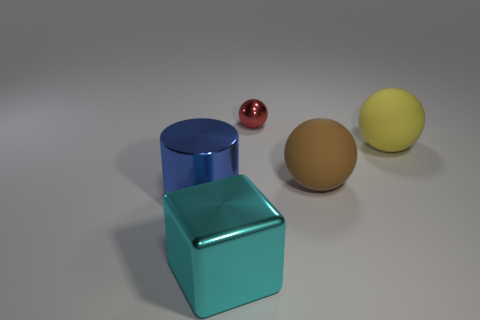Subtract all yellow matte balls. How many balls are left? 2 Subtract all red spheres. How many spheres are left? 2 Add 4 big shiny things. How many objects exist? 9 Subtract 1 balls. How many balls are left? 2 Add 2 large metallic objects. How many large metallic objects are left? 4 Add 1 yellow metal objects. How many yellow metal objects exist? 1 Subtract 1 yellow spheres. How many objects are left? 4 Subtract all blocks. How many objects are left? 4 Subtract all blue blocks. Subtract all cyan balls. How many blocks are left? 1 Subtract all green spheres. How many red cubes are left? 0 